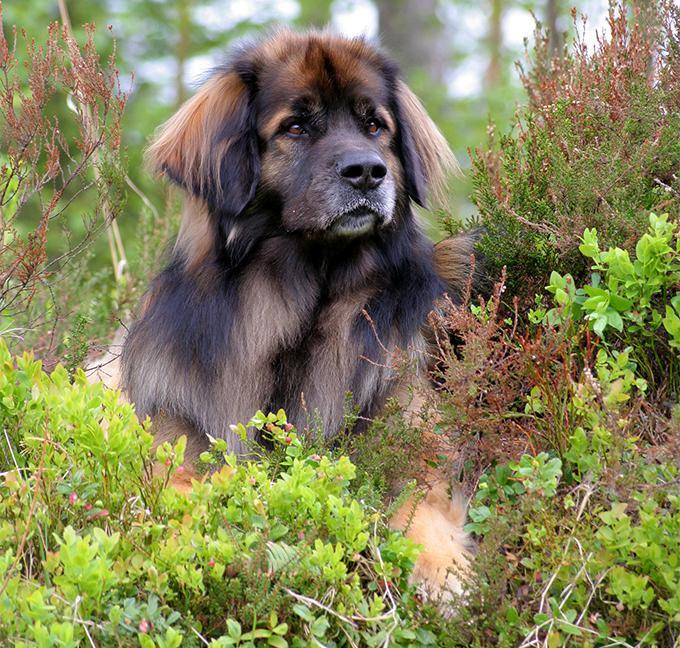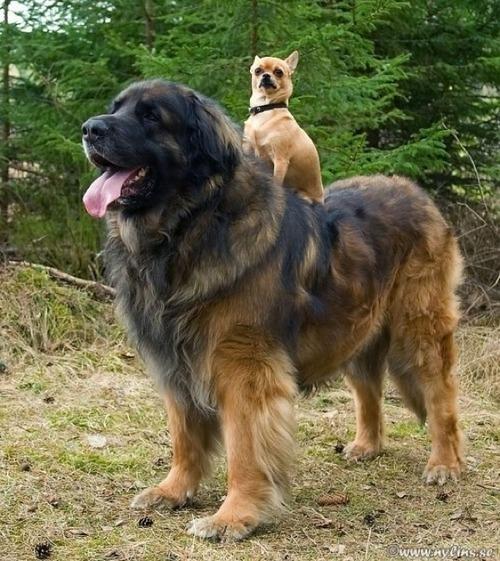The first image is the image on the left, the second image is the image on the right. For the images shown, is this caption "There are two animals in one of the images." true? Answer yes or no. Yes. 